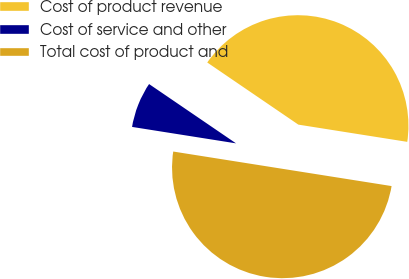Convert chart to OTSL. <chart><loc_0><loc_0><loc_500><loc_500><pie_chart><fcel>Cost of product revenue<fcel>Cost of service and other<fcel>Total cost of product and<nl><fcel>42.97%<fcel>7.03%<fcel>50.0%<nl></chart> 